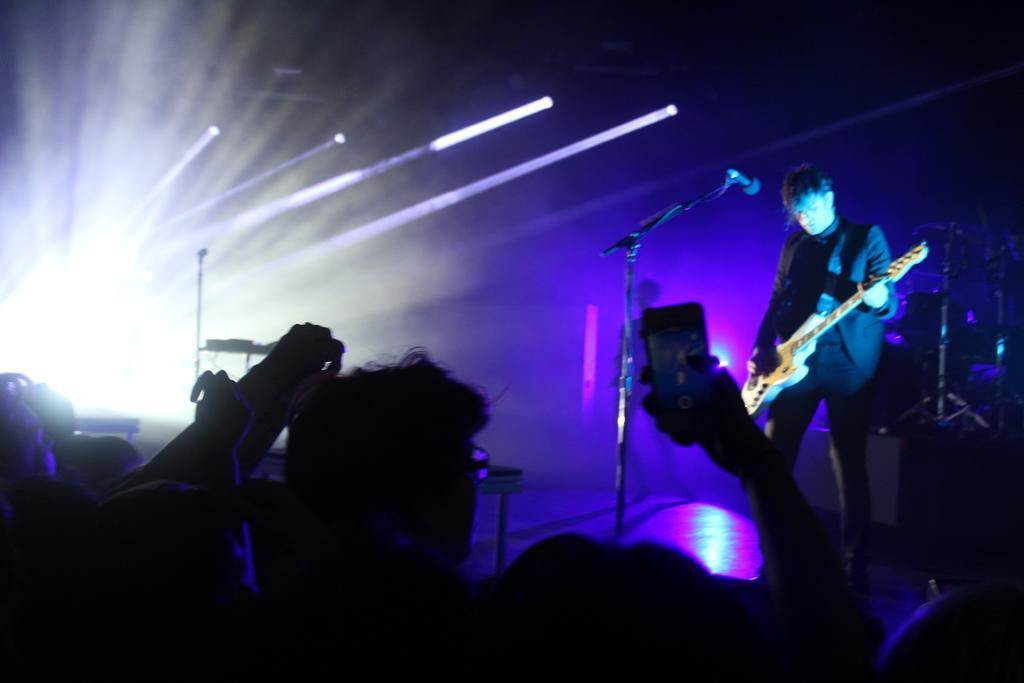Describe this image in one or two sentences. In this picture we can see person standing on a stage holding guitar in his hand and playing it and in front of him there is mic and crowd of people taking pictures of him and here we can see light shine. 